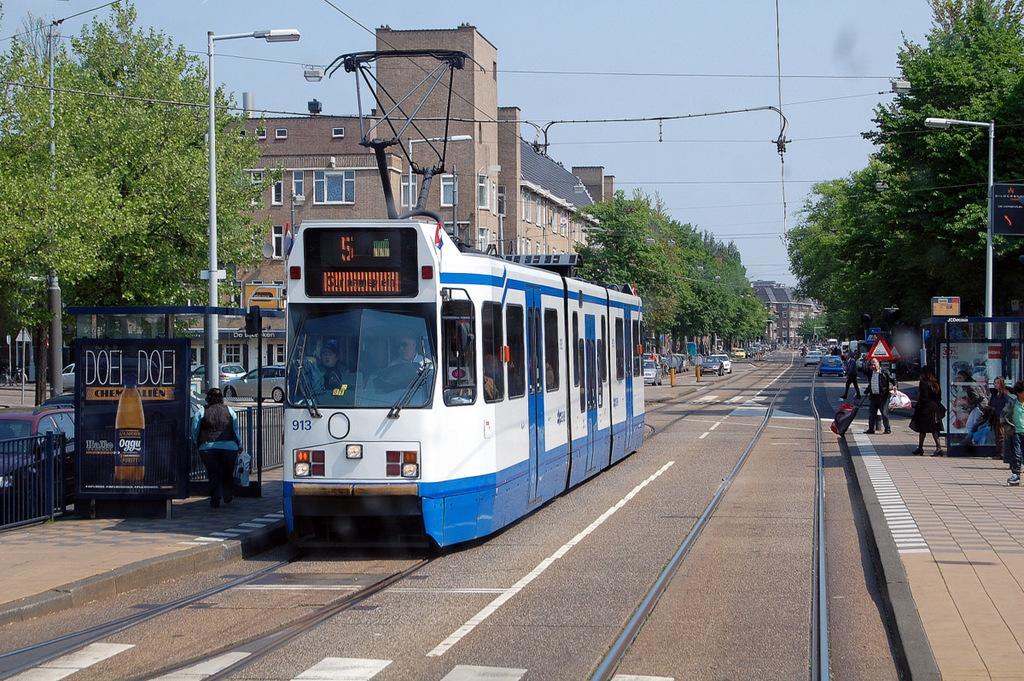Could you give a brief overview of what you see in this image? In this picture we can see the train on the track. and we can see some people standing on the footpath. This is the pole with streetlight. These are the trees. And there are some vehicles on the road. Here we can see some buildings. And on the background there is a sky. This is the sign board. 